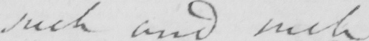What is written in this line of handwriting? such and such 